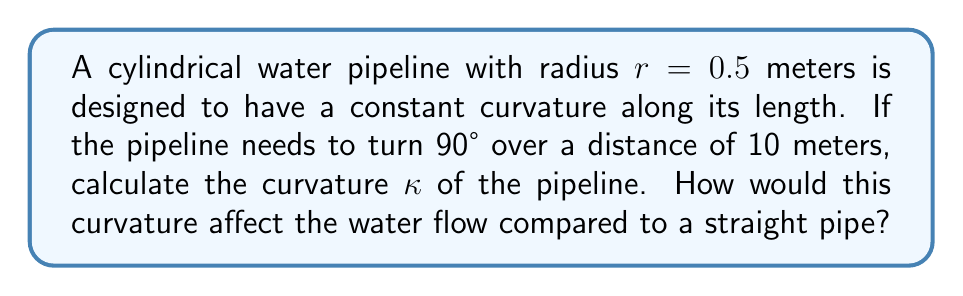Teach me how to tackle this problem. To solve this problem, we'll follow these steps:

1) The curvature $\kappa$ of a circular arc is the reciprocal of its radius of curvature $R$:

   $$\kappa = \frac{1}{R}$$

2) For a 90° turn (π/2 radians) over a distance of 10 meters, we can set up the following equation:

   $$\frac{\pi}{2} = \frac{10}{R}$$

3) Solving for R:

   $$R = \frac{20}{\pi} \approx 6.37 \text{ meters}$$

4) Now we can calculate the curvature:

   $$\kappa = \frac{1}{R} = \frac{\pi}{20} \approx 0.157 \text{ m}^{-1}$$

5) To understand how this curvature affects water flow, we can use the Dean number (De), which relates inertial forces to viscous forces in curved pipes:

   $$De = Re \sqrt{\frac{r}{R}}$$

   where Re is the Reynolds number.

6) Compared to a straight pipe (infinite R, De = 0), this curved pipe will have:
   - Increased secondary flow (circulation perpendicular to the main flow)
   - Slightly increased friction losses
   - Potential for flow separation on the inner curve at high velocities

These effects become more pronounced as the Dean number increases.
Answer: $\kappa \approx 0.157 \text{ m}^{-1}$; curved pipe increases secondary flow and friction losses 